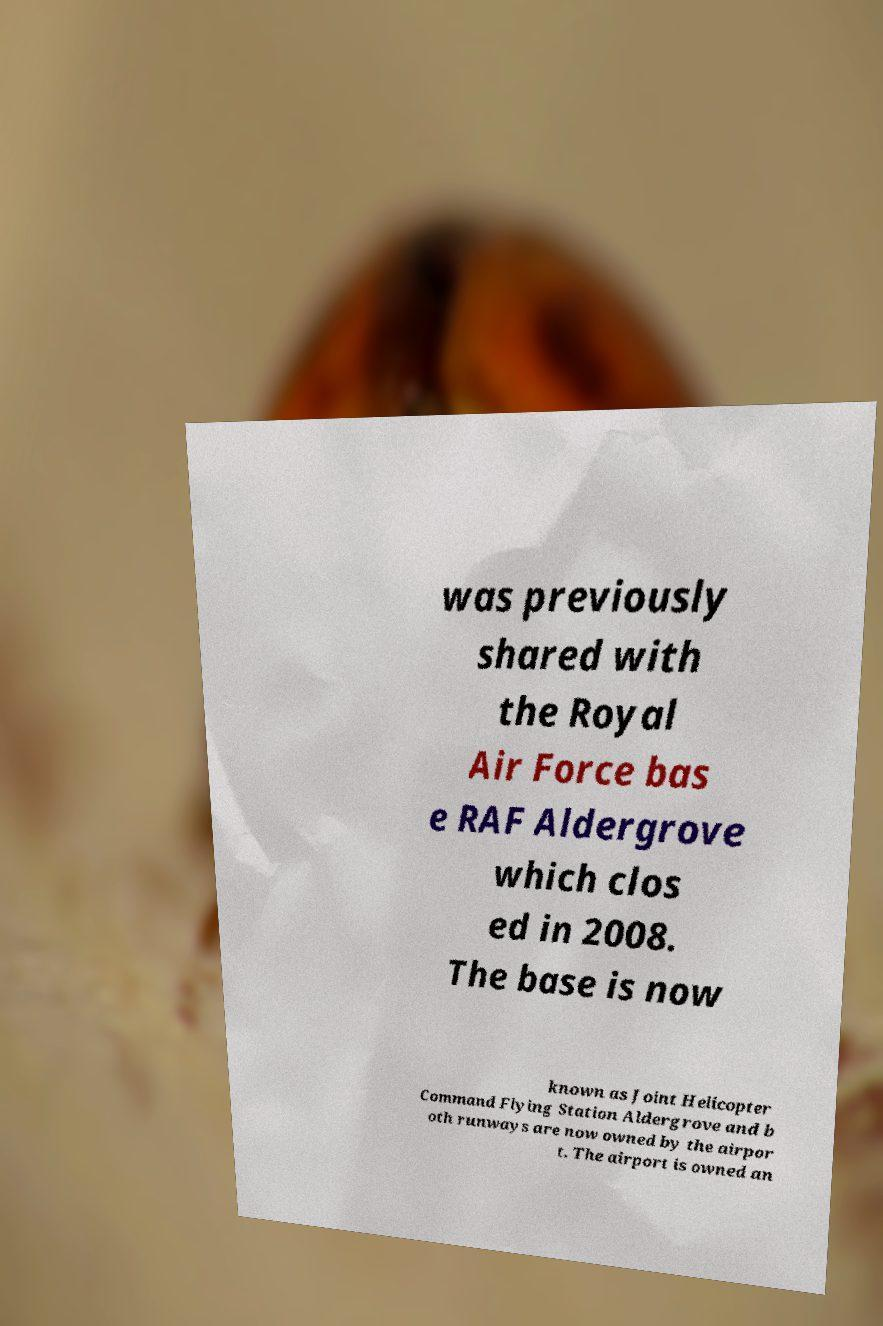Could you assist in decoding the text presented in this image and type it out clearly? was previously shared with the Royal Air Force bas e RAF Aldergrove which clos ed in 2008. The base is now known as Joint Helicopter Command Flying Station Aldergrove and b oth runways are now owned by the airpor t. The airport is owned an 